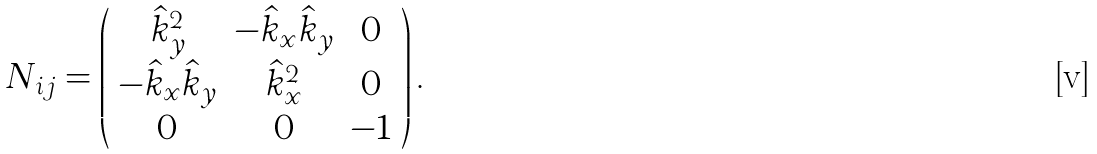<formula> <loc_0><loc_0><loc_500><loc_500>N _ { i j } = \left ( \begin{array} { c c c c } \hat { k } _ { y } ^ { 2 } & - \hat { k } _ { x } \hat { k } _ { y } & 0 \\ - \hat { k } _ { x } \hat { k } _ { y } & \hat { k } _ { x } ^ { 2 } & 0 \\ 0 & 0 & - 1 \end{array} \right ) .</formula> 